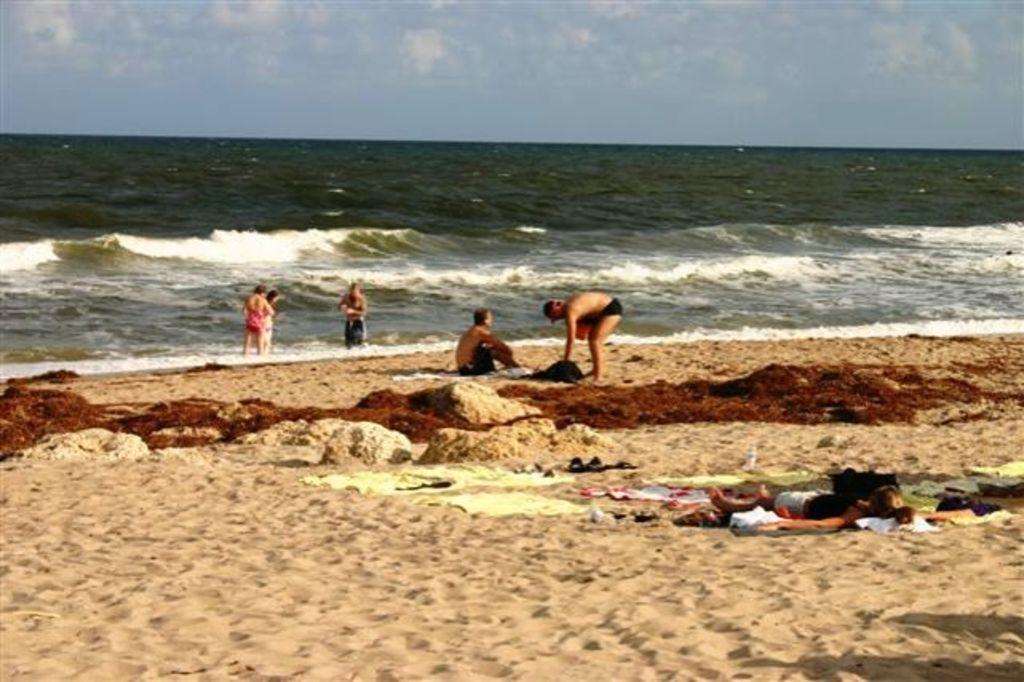Can you describe this image briefly? At the bottom of the image we can see sand. In the middle of the image we can see some people are standing, sitting, lying and we can see some clothes, bottles and footwear. Behind them we can see water. At the top of the image we can see some clouds in the sky. 